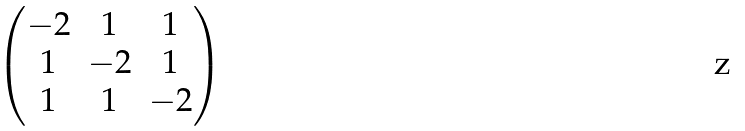Convert formula to latex. <formula><loc_0><loc_0><loc_500><loc_500>\begin{pmatrix} - 2 & 1 & 1 \\ 1 & - 2 & 1 \\ 1 & 1 & - 2 \end{pmatrix}</formula> 